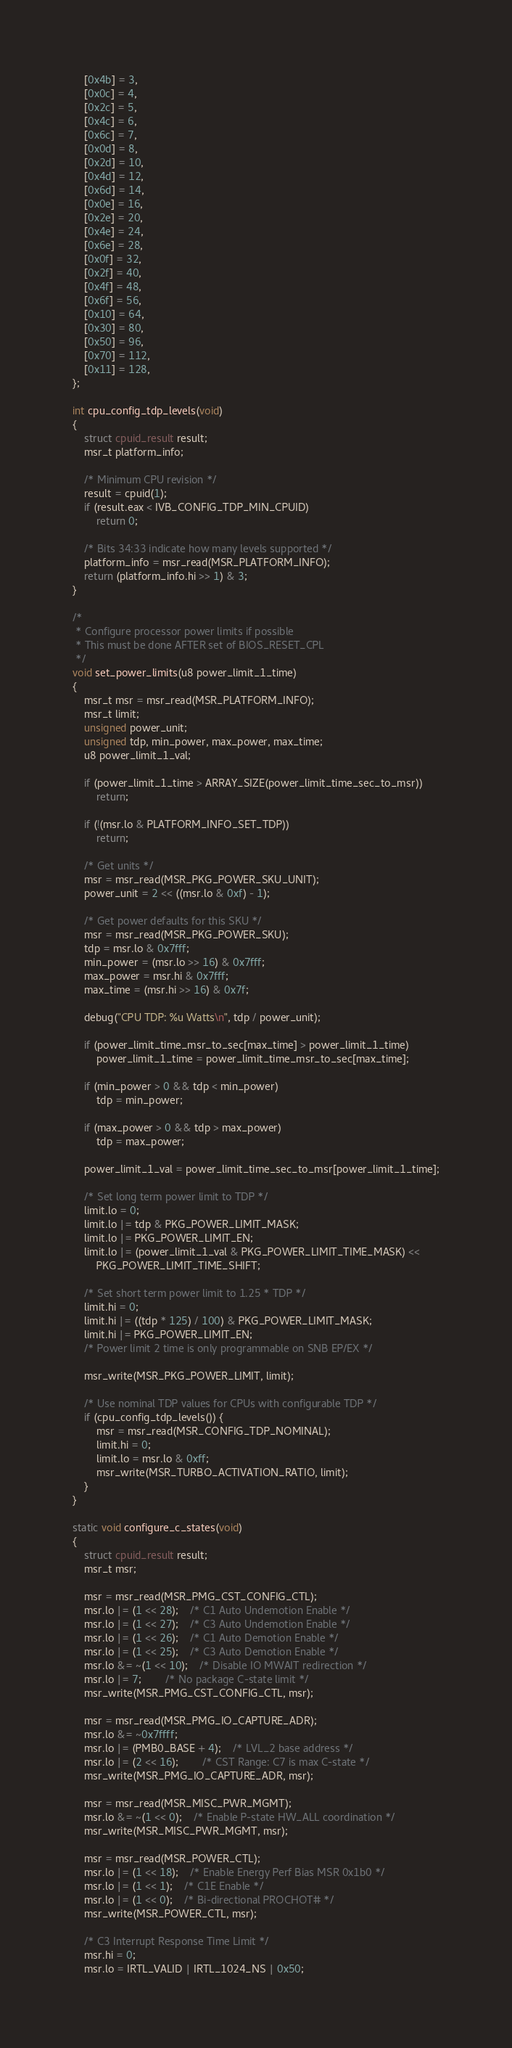Convert code to text. <code><loc_0><loc_0><loc_500><loc_500><_C_>	[0x4b] = 3,
	[0x0c] = 4,
	[0x2c] = 5,
	[0x4c] = 6,
	[0x6c] = 7,
	[0x0d] = 8,
	[0x2d] = 10,
	[0x4d] = 12,
	[0x6d] = 14,
	[0x0e] = 16,
	[0x2e] = 20,
	[0x4e] = 24,
	[0x6e] = 28,
	[0x0f] = 32,
	[0x2f] = 40,
	[0x4f] = 48,
	[0x6f] = 56,
	[0x10] = 64,
	[0x30] = 80,
	[0x50] = 96,
	[0x70] = 112,
	[0x11] = 128,
};

int cpu_config_tdp_levels(void)
{
	struct cpuid_result result;
	msr_t platform_info;

	/* Minimum CPU revision */
	result = cpuid(1);
	if (result.eax < IVB_CONFIG_TDP_MIN_CPUID)
		return 0;

	/* Bits 34:33 indicate how many levels supported */
	platform_info = msr_read(MSR_PLATFORM_INFO);
	return (platform_info.hi >> 1) & 3;
}

/*
 * Configure processor power limits if possible
 * This must be done AFTER set of BIOS_RESET_CPL
 */
void set_power_limits(u8 power_limit_1_time)
{
	msr_t msr = msr_read(MSR_PLATFORM_INFO);
	msr_t limit;
	unsigned power_unit;
	unsigned tdp, min_power, max_power, max_time;
	u8 power_limit_1_val;

	if (power_limit_1_time > ARRAY_SIZE(power_limit_time_sec_to_msr))
		return;

	if (!(msr.lo & PLATFORM_INFO_SET_TDP))
		return;

	/* Get units */
	msr = msr_read(MSR_PKG_POWER_SKU_UNIT);
	power_unit = 2 << ((msr.lo & 0xf) - 1);

	/* Get power defaults for this SKU */
	msr = msr_read(MSR_PKG_POWER_SKU);
	tdp = msr.lo & 0x7fff;
	min_power = (msr.lo >> 16) & 0x7fff;
	max_power = msr.hi & 0x7fff;
	max_time = (msr.hi >> 16) & 0x7f;

	debug("CPU TDP: %u Watts\n", tdp / power_unit);

	if (power_limit_time_msr_to_sec[max_time] > power_limit_1_time)
		power_limit_1_time = power_limit_time_msr_to_sec[max_time];

	if (min_power > 0 && tdp < min_power)
		tdp = min_power;

	if (max_power > 0 && tdp > max_power)
		tdp = max_power;

	power_limit_1_val = power_limit_time_sec_to_msr[power_limit_1_time];

	/* Set long term power limit to TDP */
	limit.lo = 0;
	limit.lo |= tdp & PKG_POWER_LIMIT_MASK;
	limit.lo |= PKG_POWER_LIMIT_EN;
	limit.lo |= (power_limit_1_val & PKG_POWER_LIMIT_TIME_MASK) <<
		PKG_POWER_LIMIT_TIME_SHIFT;

	/* Set short term power limit to 1.25 * TDP */
	limit.hi = 0;
	limit.hi |= ((tdp * 125) / 100) & PKG_POWER_LIMIT_MASK;
	limit.hi |= PKG_POWER_LIMIT_EN;
	/* Power limit 2 time is only programmable on SNB EP/EX */

	msr_write(MSR_PKG_POWER_LIMIT, limit);

	/* Use nominal TDP values for CPUs with configurable TDP */
	if (cpu_config_tdp_levels()) {
		msr = msr_read(MSR_CONFIG_TDP_NOMINAL);
		limit.hi = 0;
		limit.lo = msr.lo & 0xff;
		msr_write(MSR_TURBO_ACTIVATION_RATIO, limit);
	}
}

static void configure_c_states(void)
{
	struct cpuid_result result;
	msr_t msr;

	msr = msr_read(MSR_PMG_CST_CONFIG_CTL);
	msr.lo |= (1 << 28);	/* C1 Auto Undemotion Enable */
	msr.lo |= (1 << 27);	/* C3 Auto Undemotion Enable */
	msr.lo |= (1 << 26);	/* C1 Auto Demotion Enable */
	msr.lo |= (1 << 25);	/* C3 Auto Demotion Enable */
	msr.lo &= ~(1 << 10);	/* Disable IO MWAIT redirection */
	msr.lo |= 7;		/* No package C-state limit */
	msr_write(MSR_PMG_CST_CONFIG_CTL, msr);

	msr = msr_read(MSR_PMG_IO_CAPTURE_ADR);
	msr.lo &= ~0x7ffff;
	msr.lo |= (PMB0_BASE + 4);	/* LVL_2 base address */
	msr.lo |= (2 << 16);		/* CST Range: C7 is max C-state */
	msr_write(MSR_PMG_IO_CAPTURE_ADR, msr);

	msr = msr_read(MSR_MISC_PWR_MGMT);
	msr.lo &= ~(1 << 0);	/* Enable P-state HW_ALL coordination */
	msr_write(MSR_MISC_PWR_MGMT, msr);

	msr = msr_read(MSR_POWER_CTL);
	msr.lo |= (1 << 18);	/* Enable Energy Perf Bias MSR 0x1b0 */
	msr.lo |= (1 << 1);	/* C1E Enable */
	msr.lo |= (1 << 0);	/* Bi-directional PROCHOT# */
	msr_write(MSR_POWER_CTL, msr);

	/* C3 Interrupt Response Time Limit */
	msr.hi = 0;
	msr.lo = IRTL_VALID | IRTL_1024_NS | 0x50;</code> 